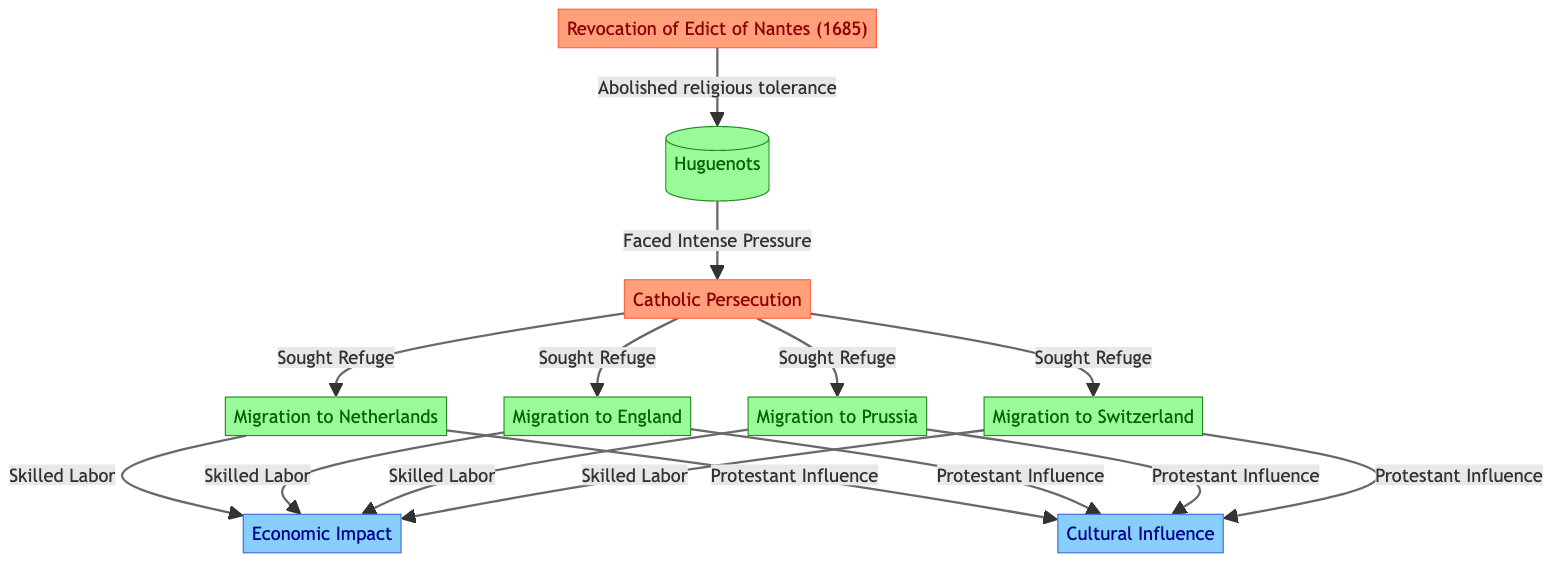What event abolished religious tolerance in France? The node labeled "Revocation of Edict of Nantes (1685)" indicates the event that abolished religious tolerance for the Huguenots.
Answer: Revocation of Edict of Nantes (1685) How many migration destinations are shown for the Huguenots? The diagram shows four migration destinations linked to the Huguenots: Netherlands, England, Prussia, and Switzerland, totaling four distinct groups.
Answer: 4 What type of impact did Huguenot migration contribute to in the receiving countries? The diagram lists "Economic Impact" and "Cultural Influence" as the two types of impacts that resulted from the skilled labor and Protestant influence of the migrants.
Answer: Economic Impact, Cultural Influence What drove the Huguenots to seek refuge? The diagram outlines the intense pressure faced by Huguenots due to "Catholic Persecution" as the driving force behind their migration to seek refuge in other countries.
Answer: Catholic Persecution Which country experienced migration from the Huguenots, according to the diagram? The diagram specifies four countries where Huguenots migrated including Netherlands, England, Prussia, and Switzerland, indicating migration out of France.
Answer: Netherlands, England, Prussia, Switzerland What was one consequence of the Huguenots being classified as a skilled labor group? The Huguenots' status as skilled laborers led to an "Economic Impact" in the countries they migrated to, as indicated in the flowchart by the connection from migration nodes to the impact.
Answer: Economic Impact 